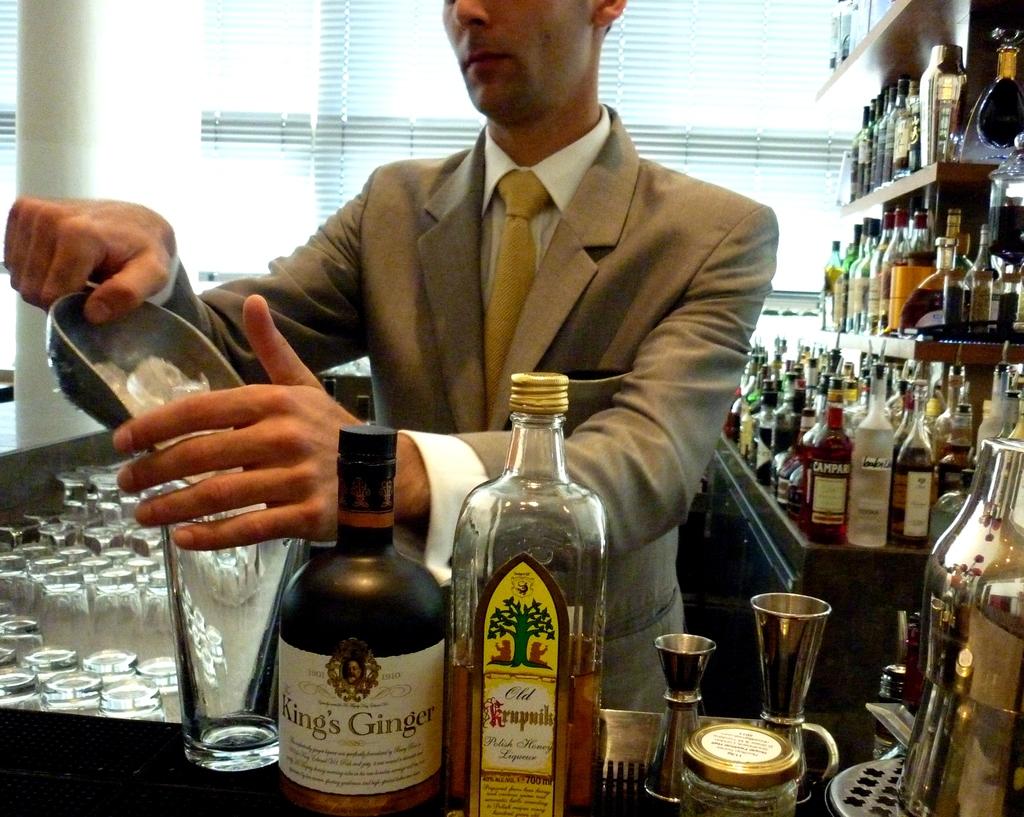What is the 3 letter word in the name on the yellow label?
Make the answer very short. Old. 